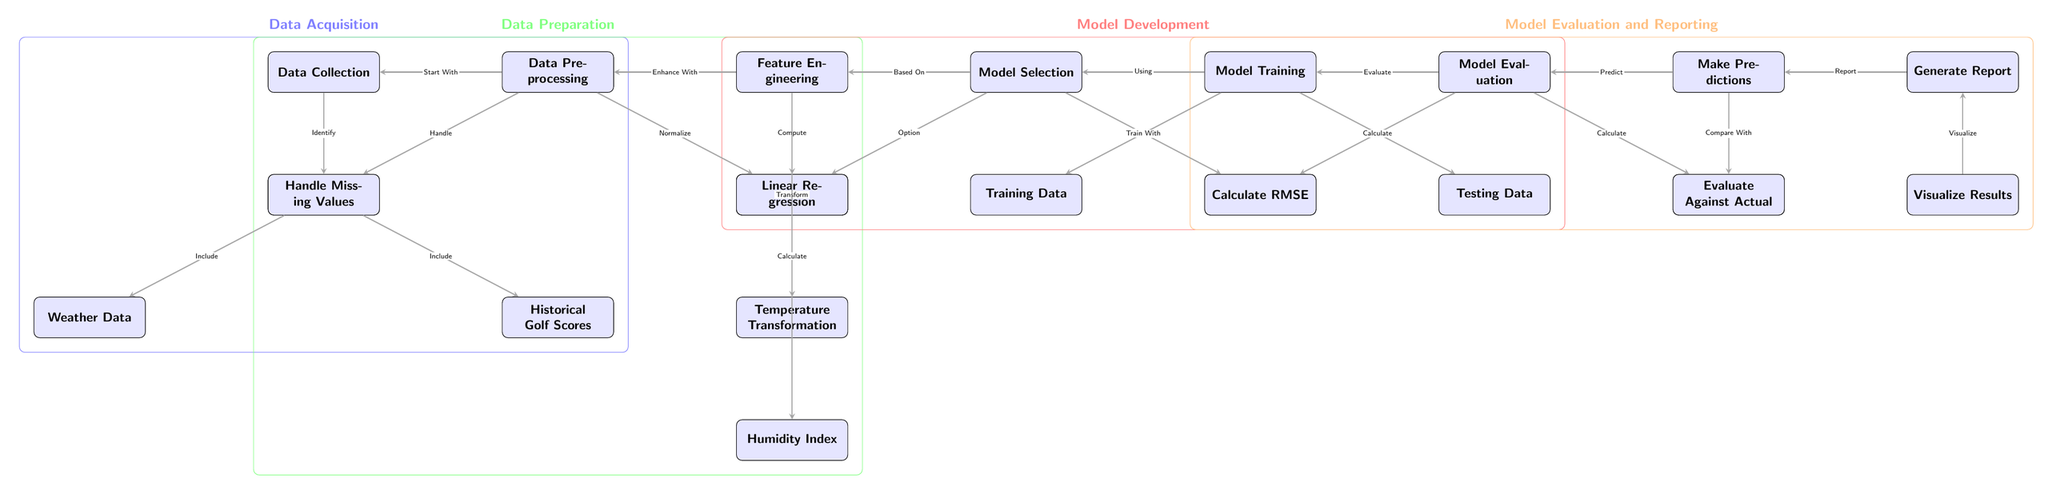What is the first node in the diagram? The first node in the diagram is "Data Collection". It is positioned at the top and initiates the flow of the diagram.
Answer: Data Collection How many main sections are there in the diagram? The diagram has four main sections: Data Acquisition, Data Preparation, Model Development, and Model Evaluation and Reporting. Each section encompasses specific nodes that contribute to the overall machine learning process.
Answer: Four Which node handles missing values? The node responsible for handling missing values is called "Handle Missing Values". It is positioned under the "Data Preprocessing" section and directly links to the "Data Collection" node.
Answer: Handle Missing Values What are the two modeling options available in the model selection stage? The two modeling options listed in the "Model Selection" stage are "Linear Regression" and "Decision Trees". They are positioned below the "Model Selection" node.
Answer: Linear Regression, Decision Trees What is the purpose of the "Training Data" node? The "Training Data" node is associated with the "Model Training" stage, where the selected model is trained using the training dataset. This is crucial for the model to learn and make predictions based on input data.
Answer: Train With How do "Temperature Transformation" and "Humidity Index" relate? Both "Temperature Transformation" and "Humidity Index" nodes are part of the "Feature Engineering" section, which aims to enhance the model's input features for better performance. They are sequentially positioned below "Calculate Wind Impact".
Answer: They enhance features What is the relationship between "Make Predictions" and "Evaluate Against Actual"? The "Make Predictions" node points to the "Evaluate Against Actual" node, indicating that after predictions are made, they will be compared against actual performance metrics to assess model accuracy.
Answer: Predict and Compare What metric is calculated during the model evaluation stage? In the "Model Evaluation" stage, the "Calculate RMSE" node is present, which indicates the calculation of Root Mean Square Error, a common metric to evaluate model performance.
Answer: Calculate RMSE Which data sources are integrated into the process? The data sources integrated into the process are "Weather Data" and "Historical Golf Scores", both essential for analyzing how environmental factors influence golf performance.
Answer: Weather Data, Historical Golf Scores 